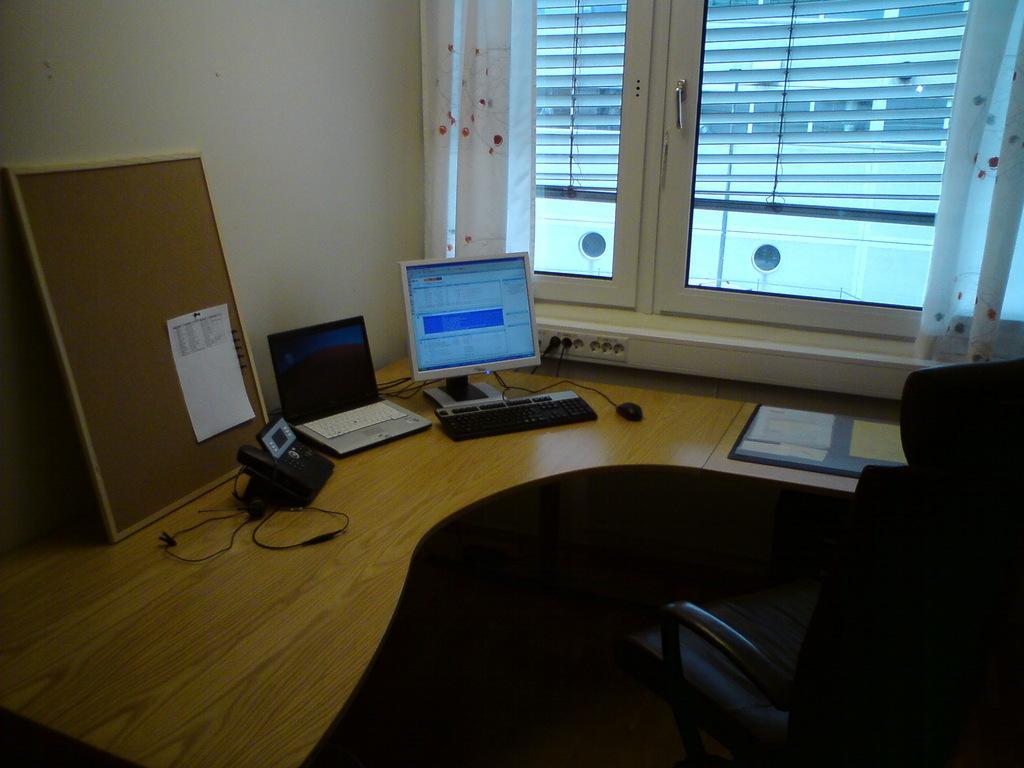Describe this image in one or two sentences. This is the picture of a room. On the right side of the image there is a chair. At the back there is a computer, laptop, keyboard, mouse, telephone and board and there are papers on the table and there is a paper on the board. There is a switch board on the wall and there is a window and there are curtains and there is a window blind behind the window and there is a building. 